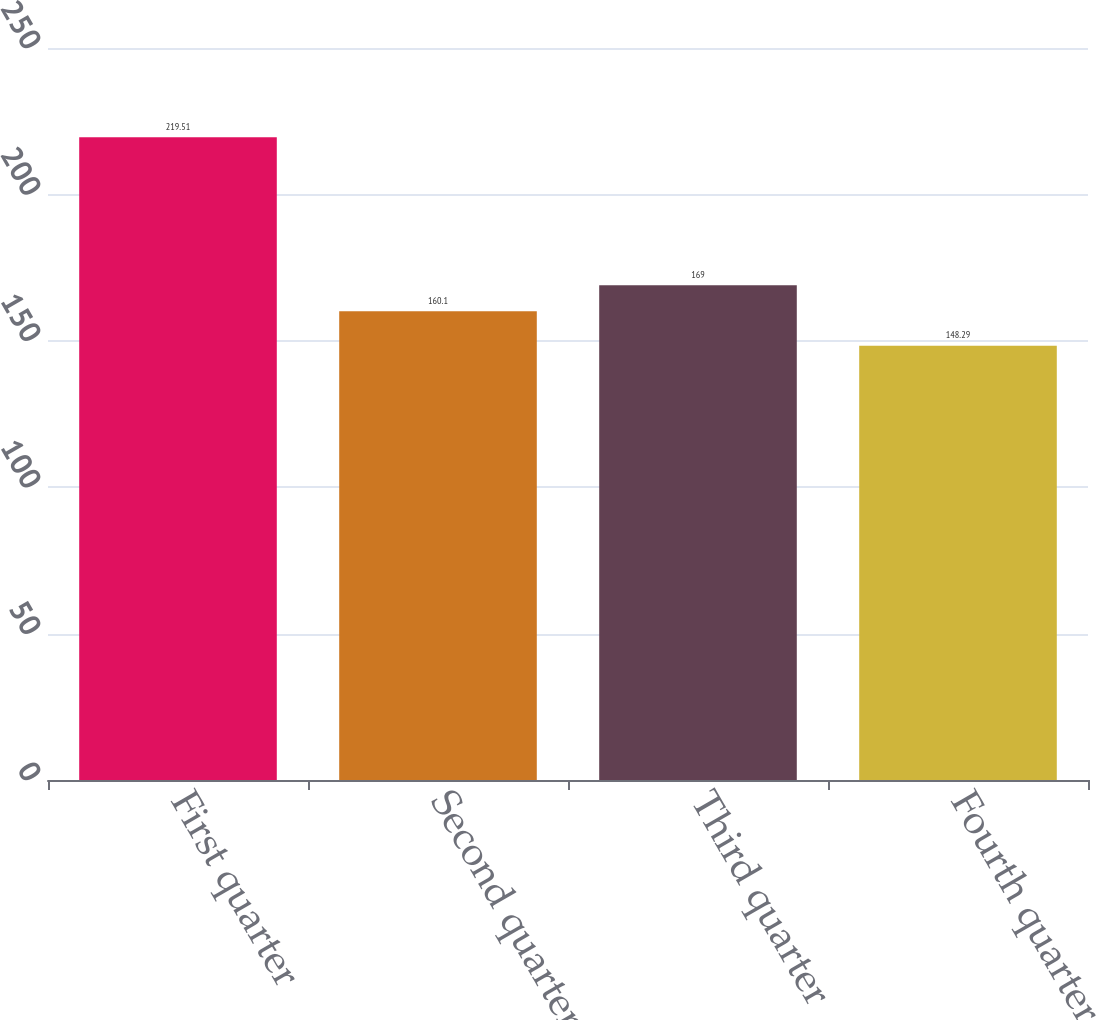Convert chart. <chart><loc_0><loc_0><loc_500><loc_500><bar_chart><fcel>First quarter<fcel>Second quarter<fcel>Third quarter<fcel>Fourth quarter<nl><fcel>219.51<fcel>160.1<fcel>169<fcel>148.29<nl></chart> 